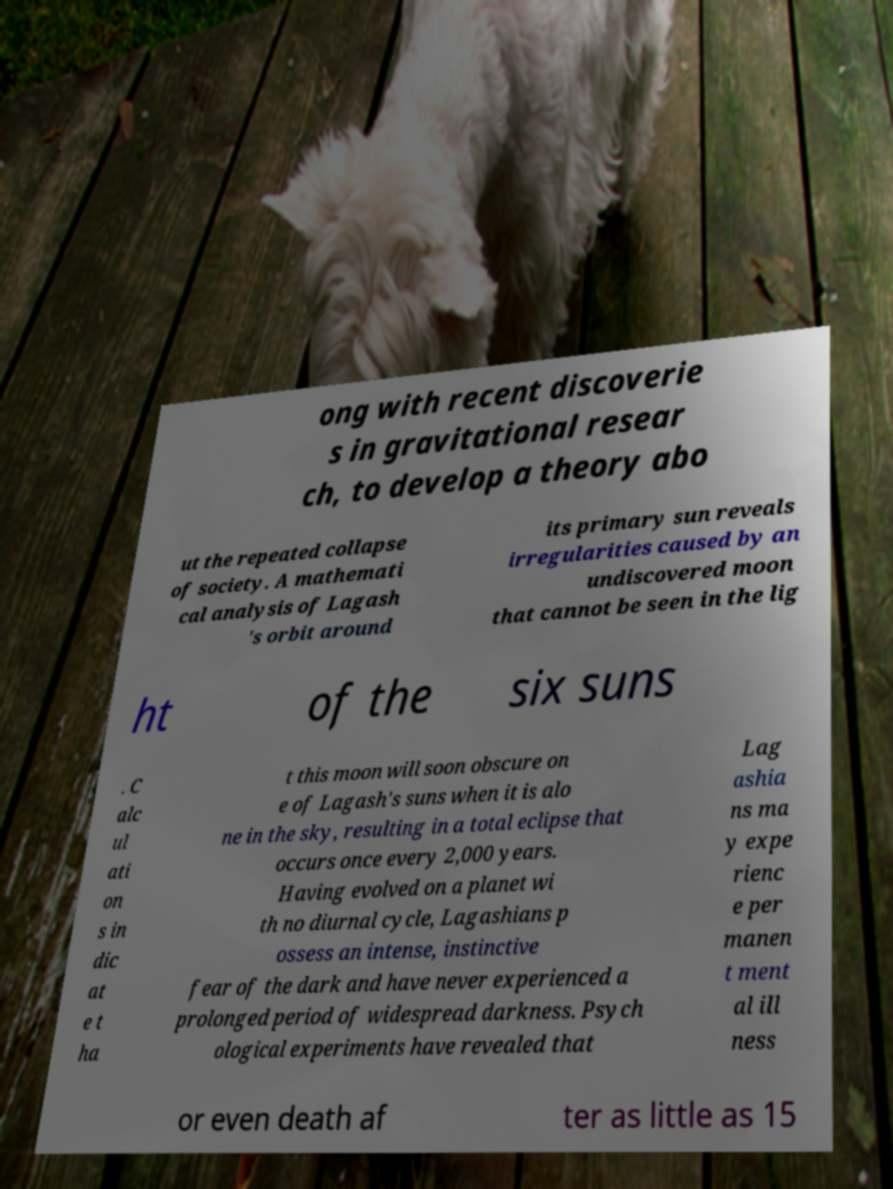For documentation purposes, I need the text within this image transcribed. Could you provide that? ong with recent discoverie s in gravitational resear ch, to develop a theory abo ut the repeated collapse of society. A mathemati cal analysis of Lagash 's orbit around its primary sun reveals irregularities caused by an undiscovered moon that cannot be seen in the lig ht of the six suns . C alc ul ati on s in dic at e t ha t this moon will soon obscure on e of Lagash's suns when it is alo ne in the sky, resulting in a total eclipse that occurs once every 2,000 years. Having evolved on a planet wi th no diurnal cycle, Lagashians p ossess an intense, instinctive fear of the dark and have never experienced a prolonged period of widespread darkness. Psych ological experiments have revealed that Lag ashia ns ma y expe rienc e per manen t ment al ill ness or even death af ter as little as 15 